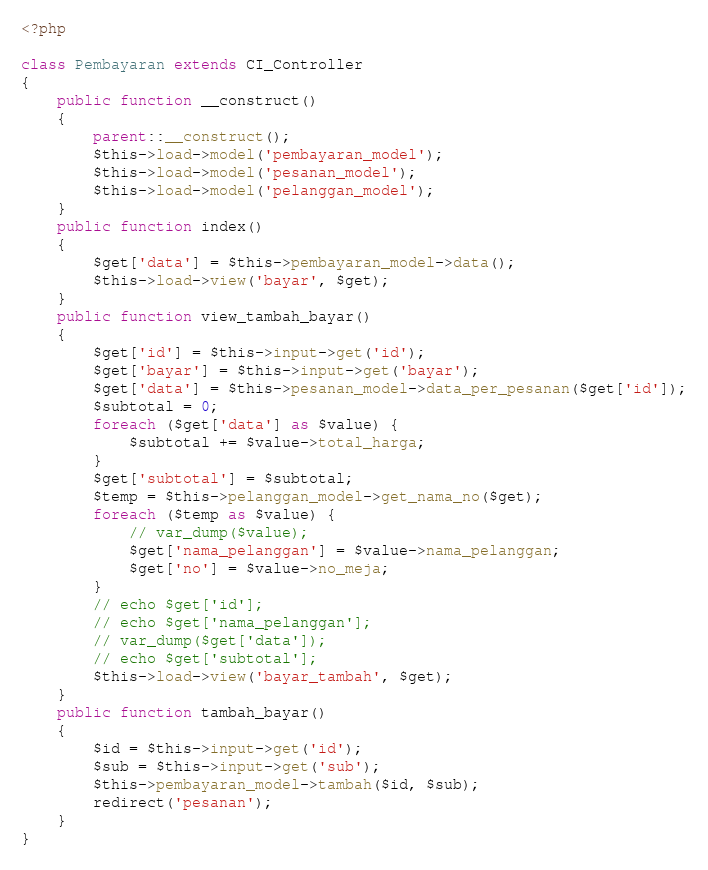Convert code to text. <code><loc_0><loc_0><loc_500><loc_500><_PHP_><?php

class Pembayaran extends CI_Controller
{
    public function __construct()
    {
        parent::__construct();
        $this->load->model('pembayaran_model');
        $this->load->model('pesanan_model');
        $this->load->model('pelanggan_model');
    }
    public function index()
    {
        $get['data'] = $this->pembayaran_model->data();
        $this->load->view('bayar', $get);
    }
    public function view_tambah_bayar()
    {
        $get['id'] = $this->input->get('id');
        $get['bayar'] = $this->input->get('bayar');
        $get['data'] = $this->pesanan_model->data_per_pesanan($get['id']);
        $subtotal = 0;
        foreach ($get['data'] as $value) {
            $subtotal += $value->total_harga;
        }
        $get['subtotal'] = $subtotal;
        $temp = $this->pelanggan_model->get_nama_no($get);
        foreach ($temp as $value) {
            // var_dump($value);
            $get['nama_pelanggan'] = $value->nama_pelanggan;
            $get['no'] = $value->no_meja;
        }
        // echo $get['id'];
        // echo $get['nama_pelanggan'];
        // var_dump($get['data']);
        // echo $get['subtotal'];
        $this->load->view('bayar_tambah', $get);
    }
    public function tambah_bayar()
    {
        $id = $this->input->get('id');
        $sub = $this->input->get('sub');
        $this->pembayaran_model->tambah($id, $sub);
        redirect('pesanan');
    }
}
</code> 